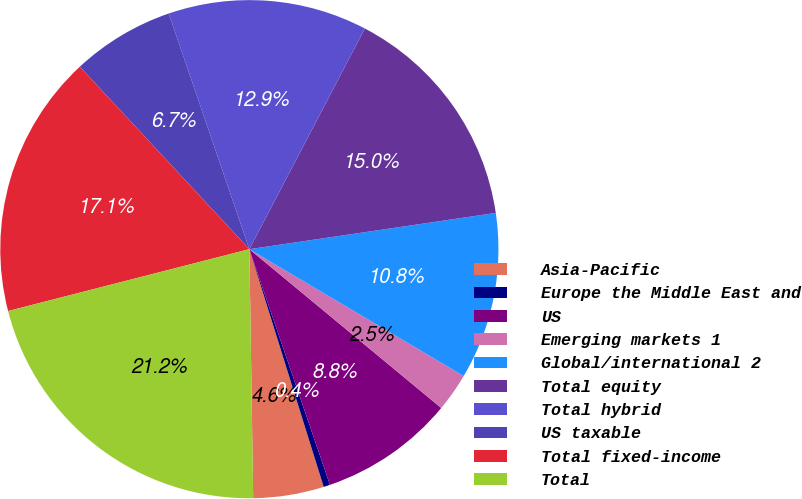Convert chart to OTSL. <chart><loc_0><loc_0><loc_500><loc_500><pie_chart><fcel>Asia-Pacific<fcel>Europe the Middle East and<fcel>US<fcel>Emerging markets 1<fcel>Global/international 2<fcel>Total equity<fcel>Total hybrid<fcel>US taxable<fcel>Total fixed-income<fcel>Total<nl><fcel>4.58%<fcel>0.42%<fcel>8.75%<fcel>2.5%<fcel>10.83%<fcel>15.0%<fcel>12.92%<fcel>6.67%<fcel>17.08%<fcel>21.25%<nl></chart> 